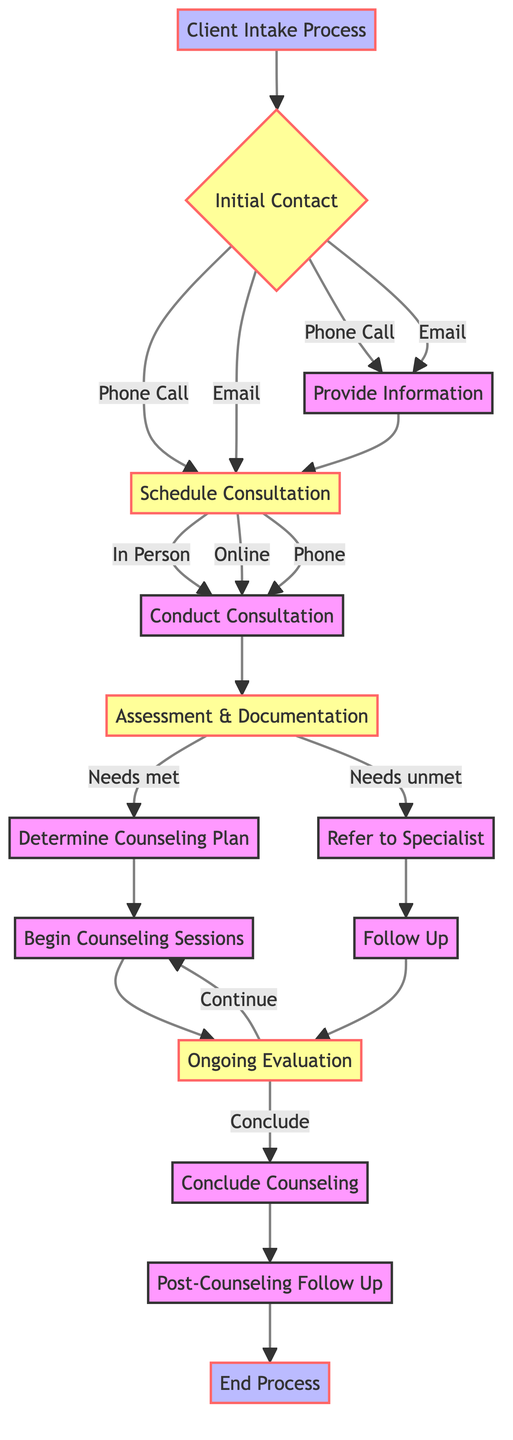What are the first options for initial contact? The diagram shows that the first options for initial contact are "Phone Call" and "Email." These options represent the ways clients can initially reach out to the counseling practice.
Answer: Phone Call, Email What is the next step after providing information? According to the flowchart, after the "Provide Information" step, the next step is "Schedule Consultation." This indicates that providing information leads directly to scheduling.
Answer: Schedule Consultation How many types of consultations are available? The diagram indicates three types of consultations that can be scheduled: "In Person," "Online," and "Phone." These options represent the various formats for the consultation meeting.
Answer: Three What happens if a client's needs are unmet during the assessment? If the client's needs are unmet during the "Assessment & Documentation" phase, the next step is "Refer to Specialist." This indicates that unmet needs lead to a referral process.
Answer: Refer to Specialist What does the process conclude with? The process culminates with the "End Process" node, indicating the conclusion of the client's intake process after post-counseling follow-up.
Answer: End Process What are the options in the ongoing evaluation phase? During the "Ongoing Evaluation" phase, the options are to either "Continue Counseling" or "Conclude Counseling." This reflects the client's ongoing treatment decisions.
Answer: Continue Counseling, Conclude Counseling How is the counseling plan developed? The counseling plan is developed after the "Assessment & Documentation" step, specifically from the "Determine Counseling Plan," which creates a tailored plan for the client based on assessed needs.
Answer: Determine Counseling Plan What is the role of the follow-up step? The "Follow Up" step occurs if the client is referred to a specialist, ensuring ongoing support and check-in after the referral, which emphasizes the continuity of care.
Answer: Follow Up 